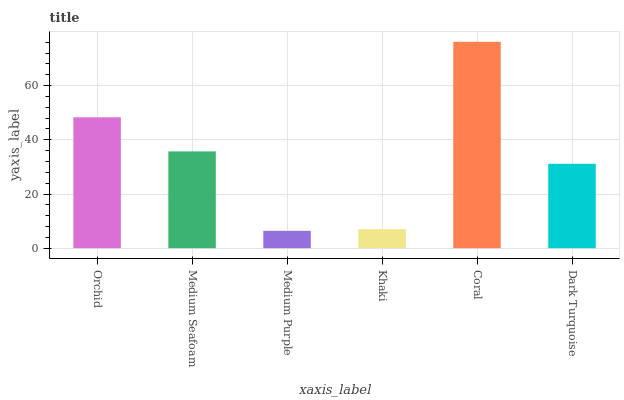Is Medium Purple the minimum?
Answer yes or no. Yes. Is Coral the maximum?
Answer yes or no. Yes. Is Medium Seafoam the minimum?
Answer yes or no. No. Is Medium Seafoam the maximum?
Answer yes or no. No. Is Orchid greater than Medium Seafoam?
Answer yes or no. Yes. Is Medium Seafoam less than Orchid?
Answer yes or no. Yes. Is Medium Seafoam greater than Orchid?
Answer yes or no. No. Is Orchid less than Medium Seafoam?
Answer yes or no. No. Is Medium Seafoam the high median?
Answer yes or no. Yes. Is Dark Turquoise the low median?
Answer yes or no. Yes. Is Medium Purple the high median?
Answer yes or no. No. Is Coral the low median?
Answer yes or no. No. 